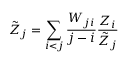Convert formula to latex. <formula><loc_0><loc_0><loc_500><loc_500>\tilde { Z } _ { j } = \sum _ { i < j } \frac { W _ { j i } } { j - i } \frac { Z _ { i } } { \tilde { Z } _ { j } }</formula> 